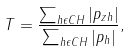<formula> <loc_0><loc_0><loc_500><loc_500>T = \frac { \sum _ { h \epsilon C H } | p _ { z h } | } { \sum _ { h \epsilon C H } | p _ { h } | } ,</formula> 